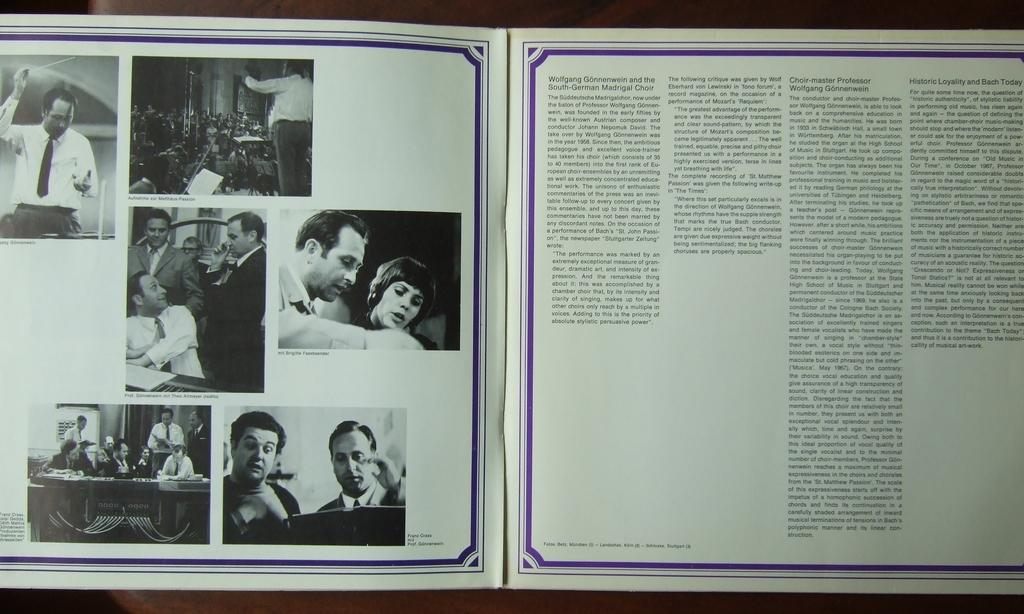Provide a one-sentence caption for the provided image. An album insert for the South-German Madrigal Choir. 